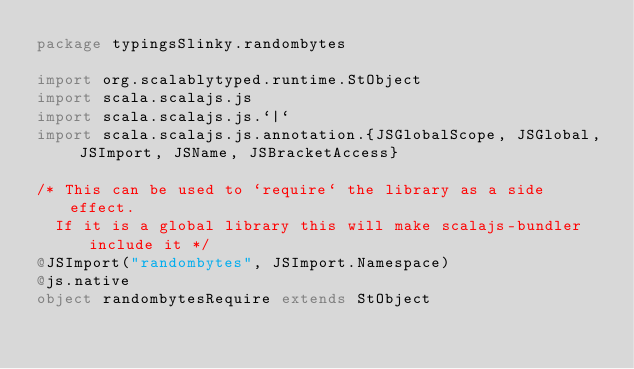<code> <loc_0><loc_0><loc_500><loc_500><_Scala_>package typingsSlinky.randombytes

import org.scalablytyped.runtime.StObject
import scala.scalajs.js
import scala.scalajs.js.`|`
import scala.scalajs.js.annotation.{JSGlobalScope, JSGlobal, JSImport, JSName, JSBracketAccess}

/* This can be used to `require` the library as a side effect.
  If it is a global library this will make scalajs-bundler include it */
@JSImport("randombytes", JSImport.Namespace)
@js.native
object randombytesRequire extends StObject
</code> 